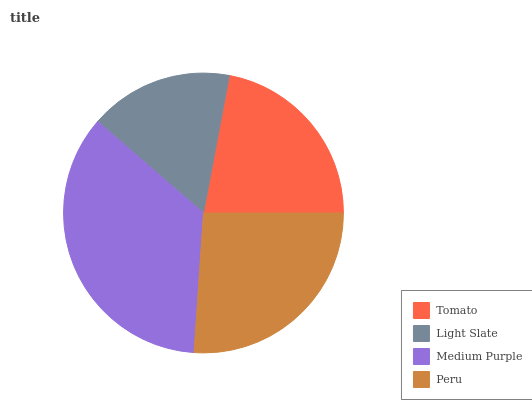Is Light Slate the minimum?
Answer yes or no. Yes. Is Medium Purple the maximum?
Answer yes or no. Yes. Is Medium Purple the minimum?
Answer yes or no. No. Is Light Slate the maximum?
Answer yes or no. No. Is Medium Purple greater than Light Slate?
Answer yes or no. Yes. Is Light Slate less than Medium Purple?
Answer yes or no. Yes. Is Light Slate greater than Medium Purple?
Answer yes or no. No. Is Medium Purple less than Light Slate?
Answer yes or no. No. Is Peru the high median?
Answer yes or no. Yes. Is Tomato the low median?
Answer yes or no. Yes. Is Tomato the high median?
Answer yes or no. No. Is Peru the low median?
Answer yes or no. No. 